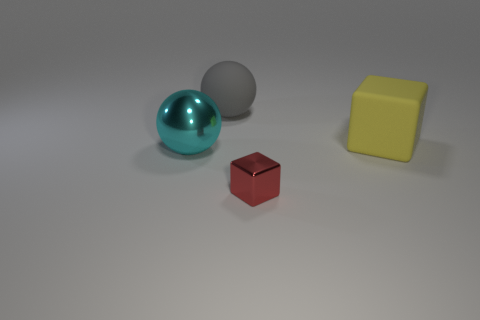There is a big rubber object that is to the left of the cube left of the matte block; what shape is it?
Give a very brief answer. Sphere. There is a rubber object to the left of the small object; does it have the same shape as the small thing?
Make the answer very short. No. Are there more gray matte spheres that are behind the red shiny thing than cyan balls behind the cyan object?
Keep it short and to the point. Yes. There is a ball that is in front of the matte ball; how many red blocks are to the left of it?
Ensure brevity in your answer.  0. The block in front of the large sphere in front of the large block is what color?
Give a very brief answer. Red. What number of rubber things are yellow objects or big brown things?
Ensure brevity in your answer.  1. Is there a yellow cube made of the same material as the large gray thing?
Offer a very short reply. Yes. What number of things are both behind the big cube and in front of the large cyan metallic sphere?
Give a very brief answer. 0. Are there fewer small shiny things behind the red metal object than shiny blocks that are in front of the cyan shiny object?
Give a very brief answer. Yes. Does the large metal object have the same shape as the tiny object?
Your answer should be compact. No. 